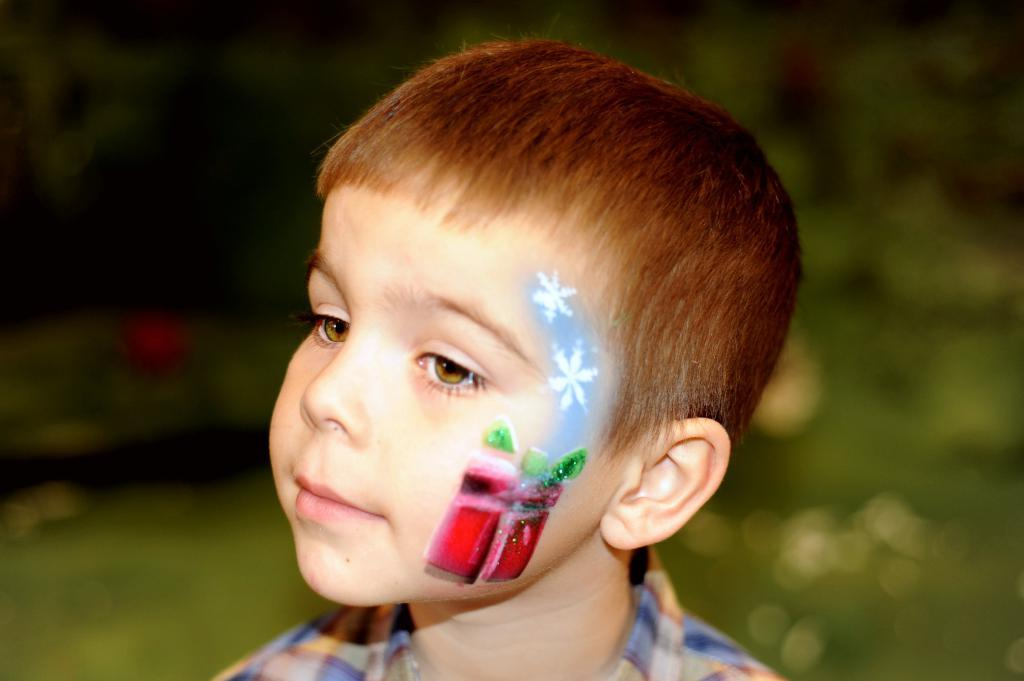Who is the main subject in the image? There is a boy in the image. What can be observed on the boy's face? The boy has red, green, blue, and white paint on his face. Can you describe the background of the image? The background of the image is blurred. What type of bead is the boy holding in his stomach in the image? There is no bead or reference to the boy's stomach in the image; he only has paint on his face. What type of soup is the boy eating in the image? There is no soup present in the image; the boy has paint on his face. 